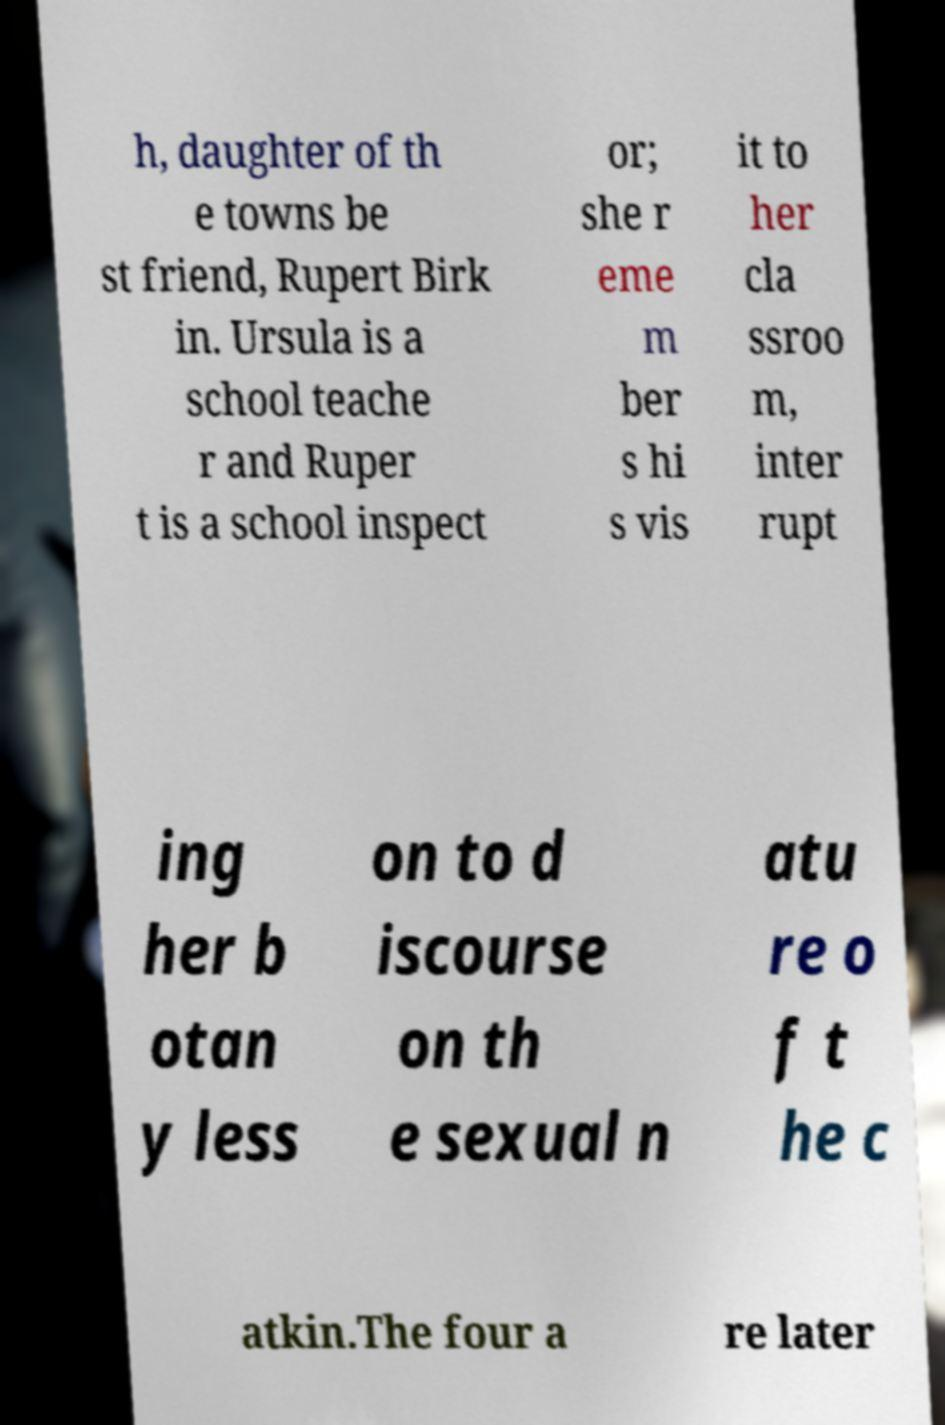Can you read and provide the text displayed in the image?This photo seems to have some interesting text. Can you extract and type it out for me? h, daughter of th e towns be st friend, Rupert Birk in. Ursula is a school teache r and Ruper t is a school inspect or; she r eme m ber s hi s vis it to her cla ssroo m, inter rupt ing her b otan y less on to d iscourse on th e sexual n atu re o f t he c atkin.The four a re later 